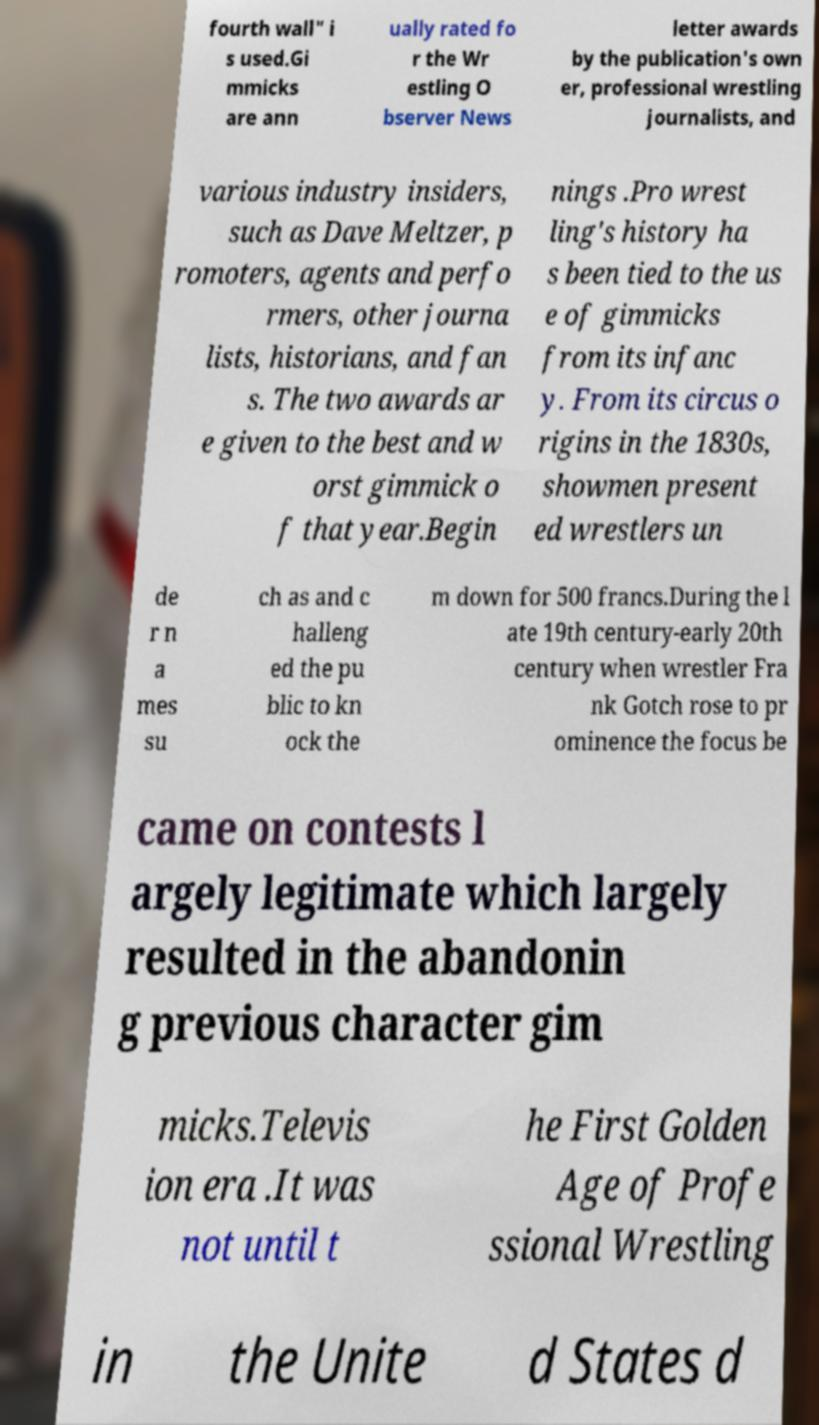Can you accurately transcribe the text from the provided image for me? fourth wall" i s used.Gi mmicks are ann ually rated fo r the Wr estling O bserver News letter awards by the publication's own er, professional wrestling journalists, and various industry insiders, such as Dave Meltzer, p romoters, agents and perfo rmers, other journa lists, historians, and fan s. The two awards ar e given to the best and w orst gimmick o f that year.Begin nings .Pro wrest ling's history ha s been tied to the us e of gimmicks from its infanc y. From its circus o rigins in the 1830s, showmen present ed wrestlers un de r n a mes su ch as and c halleng ed the pu blic to kn ock the m down for 500 francs.During the l ate 19th century-early 20th century when wrestler Fra nk Gotch rose to pr ominence the focus be came on contests l argely legitimate which largely resulted in the abandonin g previous character gim micks.Televis ion era .It was not until t he First Golden Age of Profe ssional Wrestling in the Unite d States d 